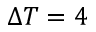<formula> <loc_0><loc_0><loc_500><loc_500>\Delta T = 4</formula> 